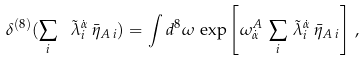Convert formula to latex. <formula><loc_0><loc_0><loc_500><loc_500>\delta ^ { ( 8 ) } ( \sum _ { i } \ \tilde { \lambda } _ { i } ^ { \dot { \alpha } } \, \bar { \eta } _ { A \, i } ) = \int d ^ { 8 } \omega \, \exp \left [ { \omega ^ { A } _ { \dot { \alpha } } \, \sum _ { i } \, \tilde { \lambda } _ { i } ^ { \dot { \alpha } } \, \bar { \eta } _ { A \, i } } \right ] \, ,</formula> 